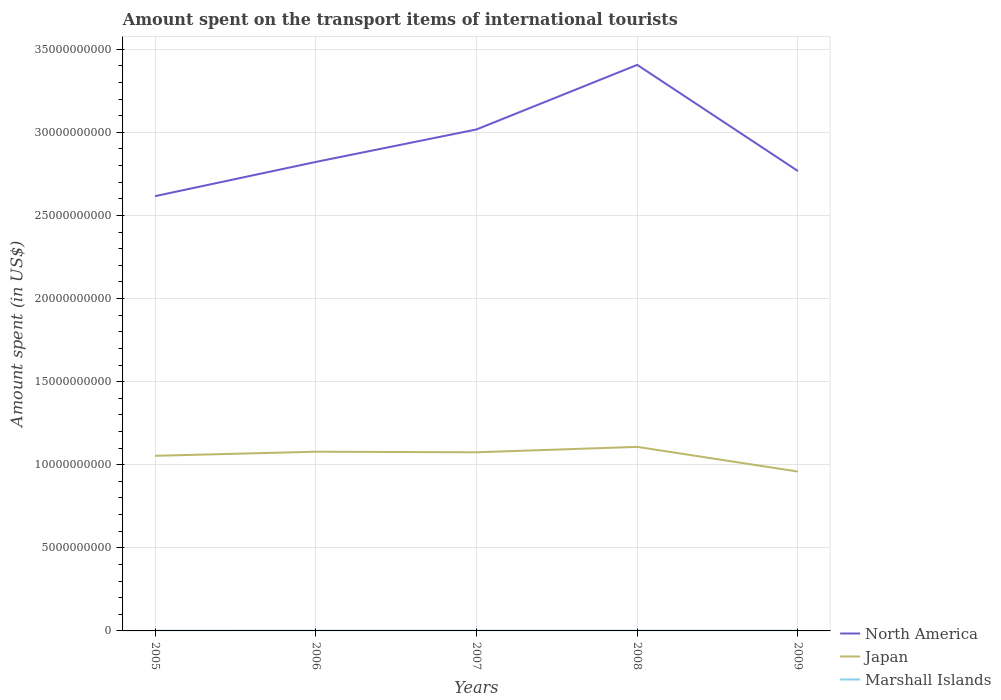Across all years, what is the maximum amount spent on the transport items of international tourists in Japan?
Provide a succinct answer. 9.59e+09. What is the total amount spent on the transport items of international tourists in Marshall Islands in the graph?
Offer a terse response. -7.00e+05. What is the difference between the highest and the second highest amount spent on the transport items of international tourists in Japan?
Provide a succinct answer. 1.49e+09. How many lines are there?
Keep it short and to the point. 3. How many years are there in the graph?
Keep it short and to the point. 5. Are the values on the major ticks of Y-axis written in scientific E-notation?
Provide a succinct answer. No. How many legend labels are there?
Provide a short and direct response. 3. What is the title of the graph?
Your answer should be compact. Amount spent on the transport items of international tourists. What is the label or title of the X-axis?
Make the answer very short. Years. What is the label or title of the Y-axis?
Make the answer very short. Amount spent (in US$). What is the Amount spent (in US$) in North America in 2005?
Your answer should be compact. 2.62e+1. What is the Amount spent (in US$) in Japan in 2005?
Offer a terse response. 1.05e+1. What is the Amount spent (in US$) in Marshall Islands in 2005?
Ensure brevity in your answer.  1.11e+07. What is the Amount spent (in US$) in North America in 2006?
Offer a very short reply. 2.82e+1. What is the Amount spent (in US$) of Japan in 2006?
Make the answer very short. 1.08e+1. What is the Amount spent (in US$) of Marshall Islands in 2006?
Your answer should be compact. 1.22e+07. What is the Amount spent (in US$) of North America in 2007?
Your answer should be compact. 3.02e+1. What is the Amount spent (in US$) of Japan in 2007?
Provide a short and direct response. 1.08e+1. What is the Amount spent (in US$) in Marshall Islands in 2007?
Keep it short and to the point. 1.29e+07. What is the Amount spent (in US$) of North America in 2008?
Provide a short and direct response. 3.41e+1. What is the Amount spent (in US$) in Japan in 2008?
Your answer should be very brief. 1.11e+1. What is the Amount spent (in US$) in Marshall Islands in 2008?
Provide a succinct answer. 1.29e+07. What is the Amount spent (in US$) of North America in 2009?
Give a very brief answer. 2.77e+1. What is the Amount spent (in US$) of Japan in 2009?
Your answer should be compact. 9.59e+09. What is the Amount spent (in US$) in Marshall Islands in 2009?
Your response must be concise. 1.22e+07. Across all years, what is the maximum Amount spent (in US$) in North America?
Offer a terse response. 3.41e+1. Across all years, what is the maximum Amount spent (in US$) in Japan?
Make the answer very short. 1.11e+1. Across all years, what is the maximum Amount spent (in US$) in Marshall Islands?
Keep it short and to the point. 1.29e+07. Across all years, what is the minimum Amount spent (in US$) in North America?
Offer a terse response. 2.62e+1. Across all years, what is the minimum Amount spent (in US$) of Japan?
Offer a terse response. 9.59e+09. Across all years, what is the minimum Amount spent (in US$) of Marshall Islands?
Keep it short and to the point. 1.11e+07. What is the total Amount spent (in US$) of North America in the graph?
Offer a terse response. 1.46e+11. What is the total Amount spent (in US$) in Japan in the graph?
Provide a short and direct response. 5.27e+1. What is the total Amount spent (in US$) in Marshall Islands in the graph?
Offer a terse response. 6.13e+07. What is the difference between the Amount spent (in US$) in North America in 2005 and that in 2006?
Your answer should be compact. -2.06e+09. What is the difference between the Amount spent (in US$) of Japan in 2005 and that in 2006?
Make the answer very short. -2.46e+08. What is the difference between the Amount spent (in US$) of Marshall Islands in 2005 and that in 2006?
Offer a terse response. -1.10e+06. What is the difference between the Amount spent (in US$) of North America in 2005 and that in 2007?
Provide a short and direct response. -4.01e+09. What is the difference between the Amount spent (in US$) in Japan in 2005 and that in 2007?
Provide a succinct answer. -2.13e+08. What is the difference between the Amount spent (in US$) in Marshall Islands in 2005 and that in 2007?
Keep it short and to the point. -1.80e+06. What is the difference between the Amount spent (in US$) in North America in 2005 and that in 2008?
Your answer should be compact. -7.90e+09. What is the difference between the Amount spent (in US$) of Japan in 2005 and that in 2008?
Give a very brief answer. -5.38e+08. What is the difference between the Amount spent (in US$) of Marshall Islands in 2005 and that in 2008?
Offer a very short reply. -1.80e+06. What is the difference between the Amount spent (in US$) of North America in 2005 and that in 2009?
Your answer should be compact. -1.51e+09. What is the difference between the Amount spent (in US$) in Japan in 2005 and that in 2009?
Your answer should be compact. 9.48e+08. What is the difference between the Amount spent (in US$) of Marshall Islands in 2005 and that in 2009?
Give a very brief answer. -1.10e+06. What is the difference between the Amount spent (in US$) of North America in 2006 and that in 2007?
Your answer should be very brief. -1.96e+09. What is the difference between the Amount spent (in US$) in Japan in 2006 and that in 2007?
Ensure brevity in your answer.  3.30e+07. What is the difference between the Amount spent (in US$) of Marshall Islands in 2006 and that in 2007?
Make the answer very short. -7.00e+05. What is the difference between the Amount spent (in US$) in North America in 2006 and that in 2008?
Ensure brevity in your answer.  -5.84e+09. What is the difference between the Amount spent (in US$) in Japan in 2006 and that in 2008?
Your answer should be compact. -2.92e+08. What is the difference between the Amount spent (in US$) in Marshall Islands in 2006 and that in 2008?
Your answer should be very brief. -7.00e+05. What is the difference between the Amount spent (in US$) in North America in 2006 and that in 2009?
Provide a succinct answer. 5.49e+08. What is the difference between the Amount spent (in US$) of Japan in 2006 and that in 2009?
Make the answer very short. 1.19e+09. What is the difference between the Amount spent (in US$) of North America in 2007 and that in 2008?
Give a very brief answer. -3.89e+09. What is the difference between the Amount spent (in US$) in Japan in 2007 and that in 2008?
Ensure brevity in your answer.  -3.25e+08. What is the difference between the Amount spent (in US$) of North America in 2007 and that in 2009?
Your answer should be compact. 2.50e+09. What is the difference between the Amount spent (in US$) in Japan in 2007 and that in 2009?
Ensure brevity in your answer.  1.16e+09. What is the difference between the Amount spent (in US$) in Marshall Islands in 2007 and that in 2009?
Provide a succinct answer. 7.00e+05. What is the difference between the Amount spent (in US$) in North America in 2008 and that in 2009?
Ensure brevity in your answer.  6.39e+09. What is the difference between the Amount spent (in US$) of Japan in 2008 and that in 2009?
Make the answer very short. 1.49e+09. What is the difference between the Amount spent (in US$) in North America in 2005 and the Amount spent (in US$) in Japan in 2006?
Your response must be concise. 1.54e+1. What is the difference between the Amount spent (in US$) of North America in 2005 and the Amount spent (in US$) of Marshall Islands in 2006?
Offer a very short reply. 2.61e+1. What is the difference between the Amount spent (in US$) of Japan in 2005 and the Amount spent (in US$) of Marshall Islands in 2006?
Your answer should be very brief. 1.05e+1. What is the difference between the Amount spent (in US$) in North America in 2005 and the Amount spent (in US$) in Japan in 2007?
Your response must be concise. 1.54e+1. What is the difference between the Amount spent (in US$) in North America in 2005 and the Amount spent (in US$) in Marshall Islands in 2007?
Keep it short and to the point. 2.61e+1. What is the difference between the Amount spent (in US$) in Japan in 2005 and the Amount spent (in US$) in Marshall Islands in 2007?
Offer a terse response. 1.05e+1. What is the difference between the Amount spent (in US$) in North America in 2005 and the Amount spent (in US$) in Japan in 2008?
Your response must be concise. 1.51e+1. What is the difference between the Amount spent (in US$) in North America in 2005 and the Amount spent (in US$) in Marshall Islands in 2008?
Make the answer very short. 2.61e+1. What is the difference between the Amount spent (in US$) of Japan in 2005 and the Amount spent (in US$) of Marshall Islands in 2008?
Offer a terse response. 1.05e+1. What is the difference between the Amount spent (in US$) in North America in 2005 and the Amount spent (in US$) in Japan in 2009?
Ensure brevity in your answer.  1.66e+1. What is the difference between the Amount spent (in US$) of North America in 2005 and the Amount spent (in US$) of Marshall Islands in 2009?
Keep it short and to the point. 2.61e+1. What is the difference between the Amount spent (in US$) of Japan in 2005 and the Amount spent (in US$) of Marshall Islands in 2009?
Keep it short and to the point. 1.05e+1. What is the difference between the Amount spent (in US$) in North America in 2006 and the Amount spent (in US$) in Japan in 2007?
Keep it short and to the point. 1.75e+1. What is the difference between the Amount spent (in US$) of North America in 2006 and the Amount spent (in US$) of Marshall Islands in 2007?
Offer a terse response. 2.82e+1. What is the difference between the Amount spent (in US$) in Japan in 2006 and the Amount spent (in US$) in Marshall Islands in 2007?
Your response must be concise. 1.08e+1. What is the difference between the Amount spent (in US$) of North America in 2006 and the Amount spent (in US$) of Japan in 2008?
Offer a very short reply. 1.71e+1. What is the difference between the Amount spent (in US$) of North America in 2006 and the Amount spent (in US$) of Marshall Islands in 2008?
Make the answer very short. 2.82e+1. What is the difference between the Amount spent (in US$) of Japan in 2006 and the Amount spent (in US$) of Marshall Islands in 2008?
Give a very brief answer. 1.08e+1. What is the difference between the Amount spent (in US$) of North America in 2006 and the Amount spent (in US$) of Japan in 2009?
Your answer should be very brief. 1.86e+1. What is the difference between the Amount spent (in US$) of North America in 2006 and the Amount spent (in US$) of Marshall Islands in 2009?
Your answer should be compact. 2.82e+1. What is the difference between the Amount spent (in US$) in Japan in 2006 and the Amount spent (in US$) in Marshall Islands in 2009?
Ensure brevity in your answer.  1.08e+1. What is the difference between the Amount spent (in US$) in North America in 2007 and the Amount spent (in US$) in Japan in 2008?
Your answer should be very brief. 1.91e+1. What is the difference between the Amount spent (in US$) of North America in 2007 and the Amount spent (in US$) of Marshall Islands in 2008?
Make the answer very short. 3.02e+1. What is the difference between the Amount spent (in US$) in Japan in 2007 and the Amount spent (in US$) in Marshall Islands in 2008?
Keep it short and to the point. 1.07e+1. What is the difference between the Amount spent (in US$) in North America in 2007 and the Amount spent (in US$) in Japan in 2009?
Offer a very short reply. 2.06e+1. What is the difference between the Amount spent (in US$) in North America in 2007 and the Amount spent (in US$) in Marshall Islands in 2009?
Make the answer very short. 3.02e+1. What is the difference between the Amount spent (in US$) in Japan in 2007 and the Amount spent (in US$) in Marshall Islands in 2009?
Make the answer very short. 1.07e+1. What is the difference between the Amount spent (in US$) in North America in 2008 and the Amount spent (in US$) in Japan in 2009?
Provide a succinct answer. 2.45e+1. What is the difference between the Amount spent (in US$) of North America in 2008 and the Amount spent (in US$) of Marshall Islands in 2009?
Ensure brevity in your answer.  3.40e+1. What is the difference between the Amount spent (in US$) of Japan in 2008 and the Amount spent (in US$) of Marshall Islands in 2009?
Your response must be concise. 1.11e+1. What is the average Amount spent (in US$) in North America per year?
Your answer should be compact. 2.93e+1. What is the average Amount spent (in US$) of Japan per year?
Your answer should be compact. 1.05e+1. What is the average Amount spent (in US$) of Marshall Islands per year?
Your answer should be compact. 1.23e+07. In the year 2005, what is the difference between the Amount spent (in US$) of North America and Amount spent (in US$) of Japan?
Provide a succinct answer. 1.56e+1. In the year 2005, what is the difference between the Amount spent (in US$) of North America and Amount spent (in US$) of Marshall Islands?
Your answer should be very brief. 2.62e+1. In the year 2005, what is the difference between the Amount spent (in US$) in Japan and Amount spent (in US$) in Marshall Islands?
Provide a short and direct response. 1.05e+1. In the year 2006, what is the difference between the Amount spent (in US$) of North America and Amount spent (in US$) of Japan?
Your answer should be very brief. 1.74e+1. In the year 2006, what is the difference between the Amount spent (in US$) of North America and Amount spent (in US$) of Marshall Islands?
Ensure brevity in your answer.  2.82e+1. In the year 2006, what is the difference between the Amount spent (in US$) in Japan and Amount spent (in US$) in Marshall Islands?
Give a very brief answer. 1.08e+1. In the year 2007, what is the difference between the Amount spent (in US$) of North America and Amount spent (in US$) of Japan?
Your answer should be very brief. 1.94e+1. In the year 2007, what is the difference between the Amount spent (in US$) of North America and Amount spent (in US$) of Marshall Islands?
Your answer should be compact. 3.02e+1. In the year 2007, what is the difference between the Amount spent (in US$) in Japan and Amount spent (in US$) in Marshall Islands?
Offer a terse response. 1.07e+1. In the year 2008, what is the difference between the Amount spent (in US$) of North America and Amount spent (in US$) of Japan?
Your response must be concise. 2.30e+1. In the year 2008, what is the difference between the Amount spent (in US$) in North America and Amount spent (in US$) in Marshall Islands?
Offer a terse response. 3.40e+1. In the year 2008, what is the difference between the Amount spent (in US$) of Japan and Amount spent (in US$) of Marshall Islands?
Offer a terse response. 1.11e+1. In the year 2009, what is the difference between the Amount spent (in US$) in North America and Amount spent (in US$) in Japan?
Your answer should be very brief. 1.81e+1. In the year 2009, what is the difference between the Amount spent (in US$) in North America and Amount spent (in US$) in Marshall Islands?
Your response must be concise. 2.77e+1. In the year 2009, what is the difference between the Amount spent (in US$) in Japan and Amount spent (in US$) in Marshall Islands?
Keep it short and to the point. 9.58e+09. What is the ratio of the Amount spent (in US$) of North America in 2005 to that in 2006?
Give a very brief answer. 0.93. What is the ratio of the Amount spent (in US$) of Japan in 2005 to that in 2006?
Offer a terse response. 0.98. What is the ratio of the Amount spent (in US$) of Marshall Islands in 2005 to that in 2006?
Keep it short and to the point. 0.91. What is the ratio of the Amount spent (in US$) in North America in 2005 to that in 2007?
Provide a short and direct response. 0.87. What is the ratio of the Amount spent (in US$) of Japan in 2005 to that in 2007?
Provide a short and direct response. 0.98. What is the ratio of the Amount spent (in US$) in Marshall Islands in 2005 to that in 2007?
Provide a short and direct response. 0.86. What is the ratio of the Amount spent (in US$) of North America in 2005 to that in 2008?
Offer a terse response. 0.77. What is the ratio of the Amount spent (in US$) in Japan in 2005 to that in 2008?
Provide a short and direct response. 0.95. What is the ratio of the Amount spent (in US$) of Marshall Islands in 2005 to that in 2008?
Offer a very short reply. 0.86. What is the ratio of the Amount spent (in US$) in North America in 2005 to that in 2009?
Provide a short and direct response. 0.95. What is the ratio of the Amount spent (in US$) of Japan in 2005 to that in 2009?
Offer a terse response. 1.1. What is the ratio of the Amount spent (in US$) in Marshall Islands in 2005 to that in 2009?
Your answer should be very brief. 0.91. What is the ratio of the Amount spent (in US$) of North America in 2006 to that in 2007?
Keep it short and to the point. 0.94. What is the ratio of the Amount spent (in US$) of Marshall Islands in 2006 to that in 2007?
Keep it short and to the point. 0.95. What is the ratio of the Amount spent (in US$) of North America in 2006 to that in 2008?
Make the answer very short. 0.83. What is the ratio of the Amount spent (in US$) of Japan in 2006 to that in 2008?
Offer a very short reply. 0.97. What is the ratio of the Amount spent (in US$) in Marshall Islands in 2006 to that in 2008?
Make the answer very short. 0.95. What is the ratio of the Amount spent (in US$) in North America in 2006 to that in 2009?
Offer a terse response. 1.02. What is the ratio of the Amount spent (in US$) in Japan in 2006 to that in 2009?
Provide a succinct answer. 1.12. What is the ratio of the Amount spent (in US$) of North America in 2007 to that in 2008?
Make the answer very short. 0.89. What is the ratio of the Amount spent (in US$) in Japan in 2007 to that in 2008?
Your response must be concise. 0.97. What is the ratio of the Amount spent (in US$) in North America in 2007 to that in 2009?
Provide a succinct answer. 1.09. What is the ratio of the Amount spent (in US$) in Japan in 2007 to that in 2009?
Give a very brief answer. 1.12. What is the ratio of the Amount spent (in US$) of Marshall Islands in 2007 to that in 2009?
Your response must be concise. 1.06. What is the ratio of the Amount spent (in US$) of North America in 2008 to that in 2009?
Provide a short and direct response. 1.23. What is the ratio of the Amount spent (in US$) of Japan in 2008 to that in 2009?
Keep it short and to the point. 1.16. What is the ratio of the Amount spent (in US$) in Marshall Islands in 2008 to that in 2009?
Your answer should be compact. 1.06. What is the difference between the highest and the second highest Amount spent (in US$) in North America?
Make the answer very short. 3.89e+09. What is the difference between the highest and the second highest Amount spent (in US$) in Japan?
Offer a very short reply. 2.92e+08. What is the difference between the highest and the lowest Amount spent (in US$) of North America?
Provide a short and direct response. 7.90e+09. What is the difference between the highest and the lowest Amount spent (in US$) of Japan?
Give a very brief answer. 1.49e+09. What is the difference between the highest and the lowest Amount spent (in US$) in Marshall Islands?
Provide a succinct answer. 1.80e+06. 